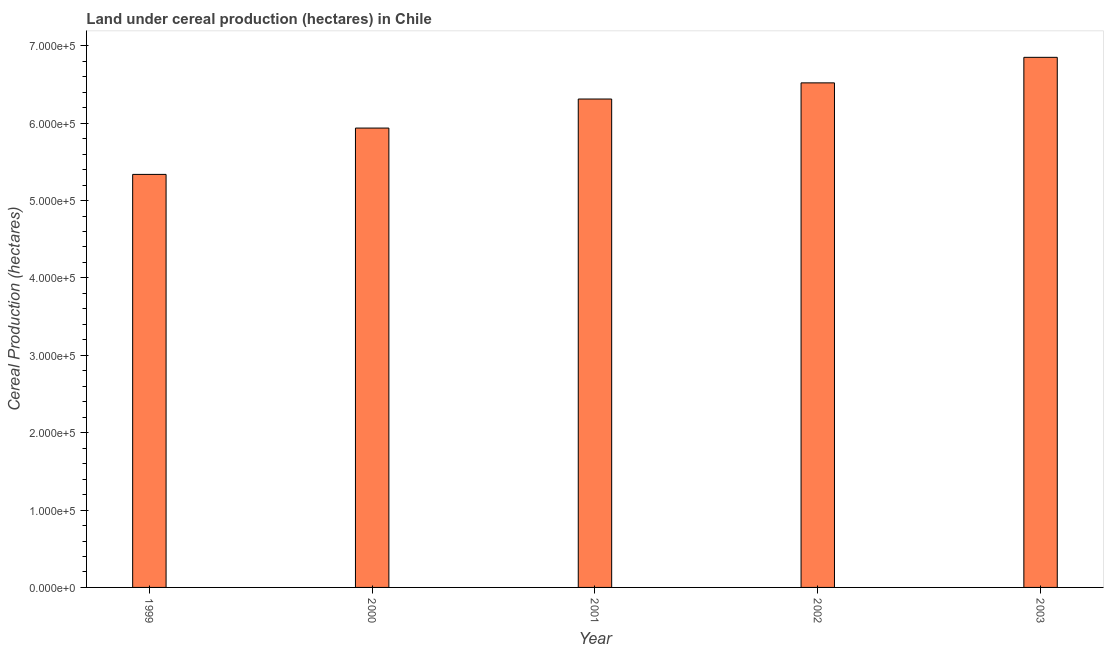Does the graph contain any zero values?
Provide a short and direct response. No. What is the title of the graph?
Make the answer very short. Land under cereal production (hectares) in Chile. What is the label or title of the Y-axis?
Give a very brief answer. Cereal Production (hectares). What is the land under cereal production in 2000?
Offer a very short reply. 5.94e+05. Across all years, what is the maximum land under cereal production?
Offer a terse response. 6.85e+05. Across all years, what is the minimum land under cereal production?
Your answer should be very brief. 5.34e+05. What is the sum of the land under cereal production?
Ensure brevity in your answer.  3.10e+06. What is the difference between the land under cereal production in 2000 and 2001?
Provide a succinct answer. -3.76e+04. What is the average land under cereal production per year?
Give a very brief answer. 6.19e+05. What is the median land under cereal production?
Give a very brief answer. 6.31e+05. In how many years, is the land under cereal production greater than 400000 hectares?
Provide a succinct answer. 5. What is the ratio of the land under cereal production in 2001 to that in 2002?
Your answer should be compact. 0.97. Is the land under cereal production in 1999 less than that in 2002?
Give a very brief answer. Yes. What is the difference between the highest and the second highest land under cereal production?
Offer a very short reply. 3.30e+04. What is the difference between the highest and the lowest land under cereal production?
Your answer should be compact. 1.51e+05. In how many years, is the land under cereal production greater than the average land under cereal production taken over all years?
Offer a terse response. 3. How many years are there in the graph?
Give a very brief answer. 5. What is the Cereal Production (hectares) in 1999?
Make the answer very short. 5.34e+05. What is the Cereal Production (hectares) of 2000?
Offer a terse response. 5.94e+05. What is the Cereal Production (hectares) of 2001?
Give a very brief answer. 6.31e+05. What is the Cereal Production (hectares) of 2002?
Offer a very short reply. 6.52e+05. What is the Cereal Production (hectares) of 2003?
Offer a terse response. 6.85e+05. What is the difference between the Cereal Production (hectares) in 1999 and 2000?
Your answer should be very brief. -5.99e+04. What is the difference between the Cereal Production (hectares) in 1999 and 2001?
Give a very brief answer. -9.74e+04. What is the difference between the Cereal Production (hectares) in 1999 and 2002?
Your response must be concise. -1.18e+05. What is the difference between the Cereal Production (hectares) in 1999 and 2003?
Provide a short and direct response. -1.51e+05. What is the difference between the Cereal Production (hectares) in 2000 and 2001?
Your answer should be very brief. -3.76e+04. What is the difference between the Cereal Production (hectares) in 2000 and 2002?
Your response must be concise. -5.84e+04. What is the difference between the Cereal Production (hectares) in 2000 and 2003?
Offer a terse response. -9.14e+04. What is the difference between the Cereal Production (hectares) in 2001 and 2002?
Offer a very short reply. -2.09e+04. What is the difference between the Cereal Production (hectares) in 2001 and 2003?
Make the answer very short. -5.39e+04. What is the difference between the Cereal Production (hectares) in 2002 and 2003?
Give a very brief answer. -3.30e+04. What is the ratio of the Cereal Production (hectares) in 1999 to that in 2000?
Offer a terse response. 0.9. What is the ratio of the Cereal Production (hectares) in 1999 to that in 2001?
Keep it short and to the point. 0.85. What is the ratio of the Cereal Production (hectares) in 1999 to that in 2002?
Keep it short and to the point. 0.82. What is the ratio of the Cereal Production (hectares) in 1999 to that in 2003?
Provide a short and direct response. 0.78. What is the ratio of the Cereal Production (hectares) in 2000 to that in 2001?
Ensure brevity in your answer.  0.94. What is the ratio of the Cereal Production (hectares) in 2000 to that in 2002?
Offer a terse response. 0.91. What is the ratio of the Cereal Production (hectares) in 2000 to that in 2003?
Your response must be concise. 0.87. What is the ratio of the Cereal Production (hectares) in 2001 to that in 2002?
Give a very brief answer. 0.97. What is the ratio of the Cereal Production (hectares) in 2001 to that in 2003?
Your response must be concise. 0.92. What is the ratio of the Cereal Production (hectares) in 2002 to that in 2003?
Your answer should be very brief. 0.95. 